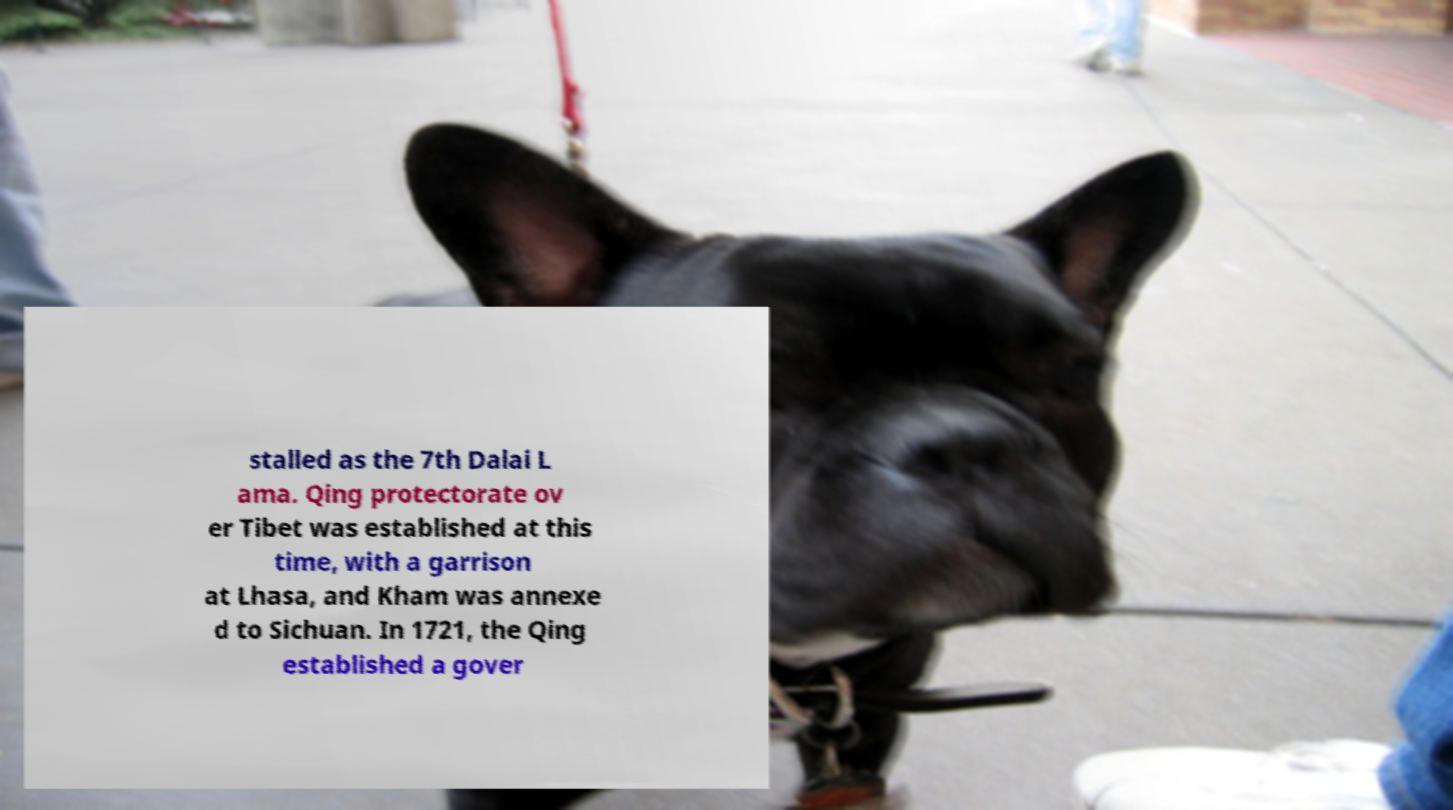For documentation purposes, I need the text within this image transcribed. Could you provide that? stalled as the 7th Dalai L ama. Qing protectorate ov er Tibet was established at this time, with a garrison at Lhasa, and Kham was annexe d to Sichuan. In 1721, the Qing established a gover 